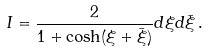<formula> <loc_0><loc_0><loc_500><loc_500>I = \frac { 2 } { 1 + \cosh ( \xi + \bar { \xi } ) } d \xi d \bar { \xi } \, .</formula> 